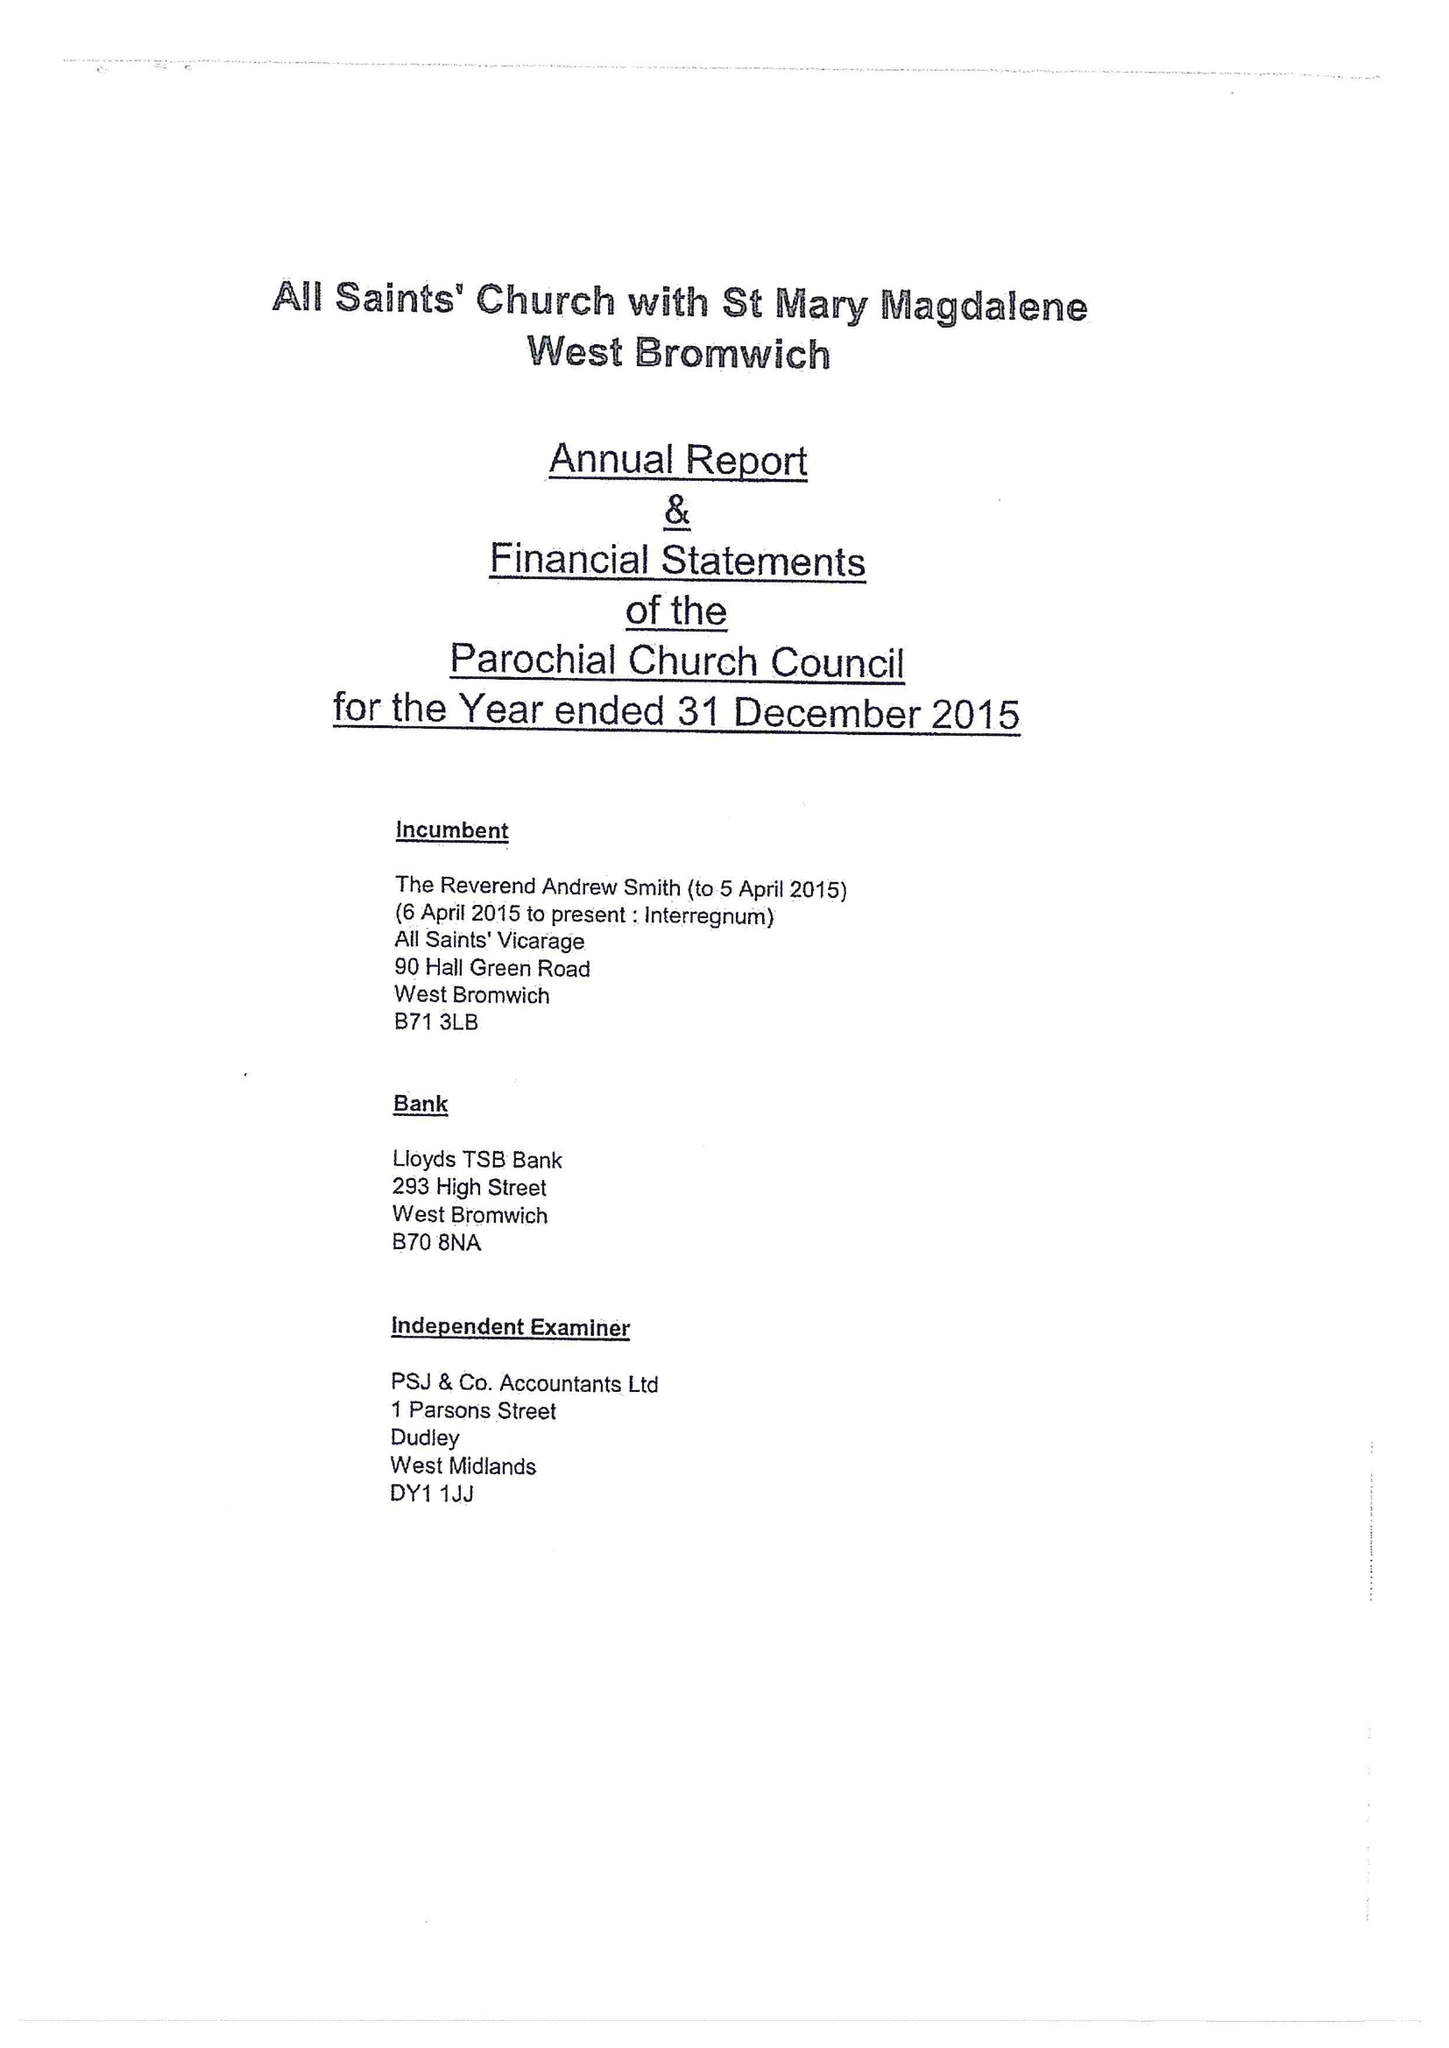What is the value for the spending_annually_in_british_pounds?
Answer the question using a single word or phrase. 153164.08 